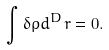Convert formula to latex. <formula><loc_0><loc_0><loc_500><loc_500>\int \delta \rho d ^ { D } { r } = 0 .</formula> 